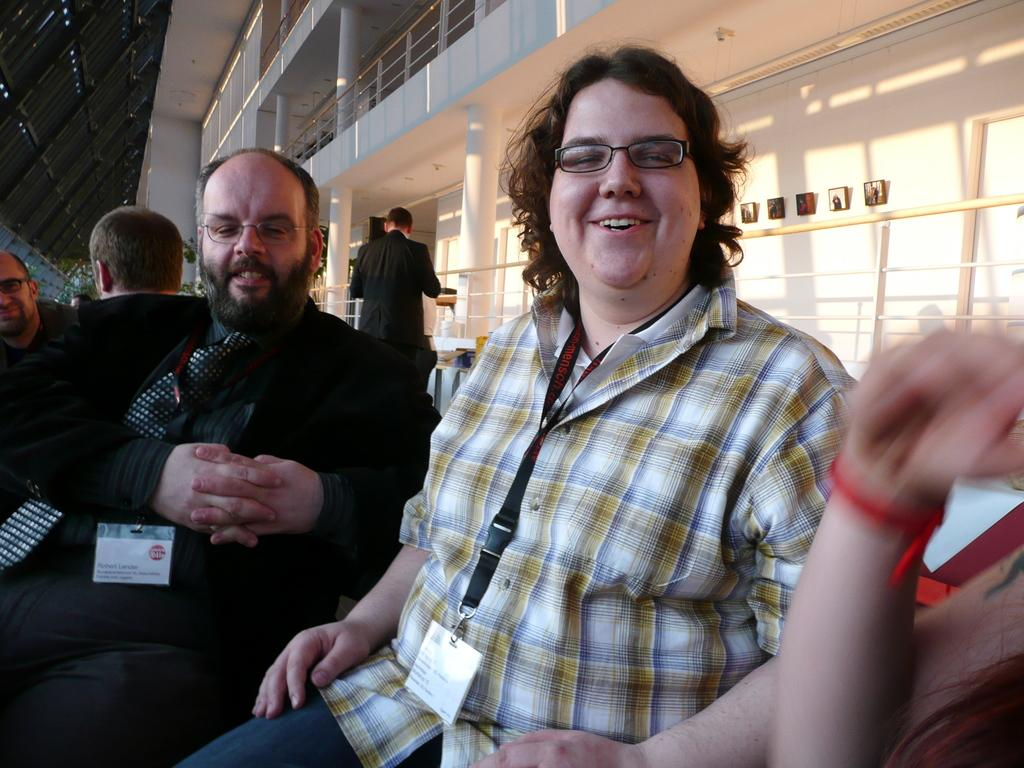How many people can be seen in the image? There are a few people in the image. What is located on the wall in the image? There is a wall with some objects in the image. What type of barrier is present in the image? There is a fence in the image. Where are some objects located in the image? There are a few objects on the left side of the image. What architectural features can be seen in the image? There are pillars in the image. What type of flesh can be seen on the pillars in the image? There is no flesh present on the pillars in the image. Is there an umbrella being used by any of the people in the image? There is no umbrella visible in the image. 